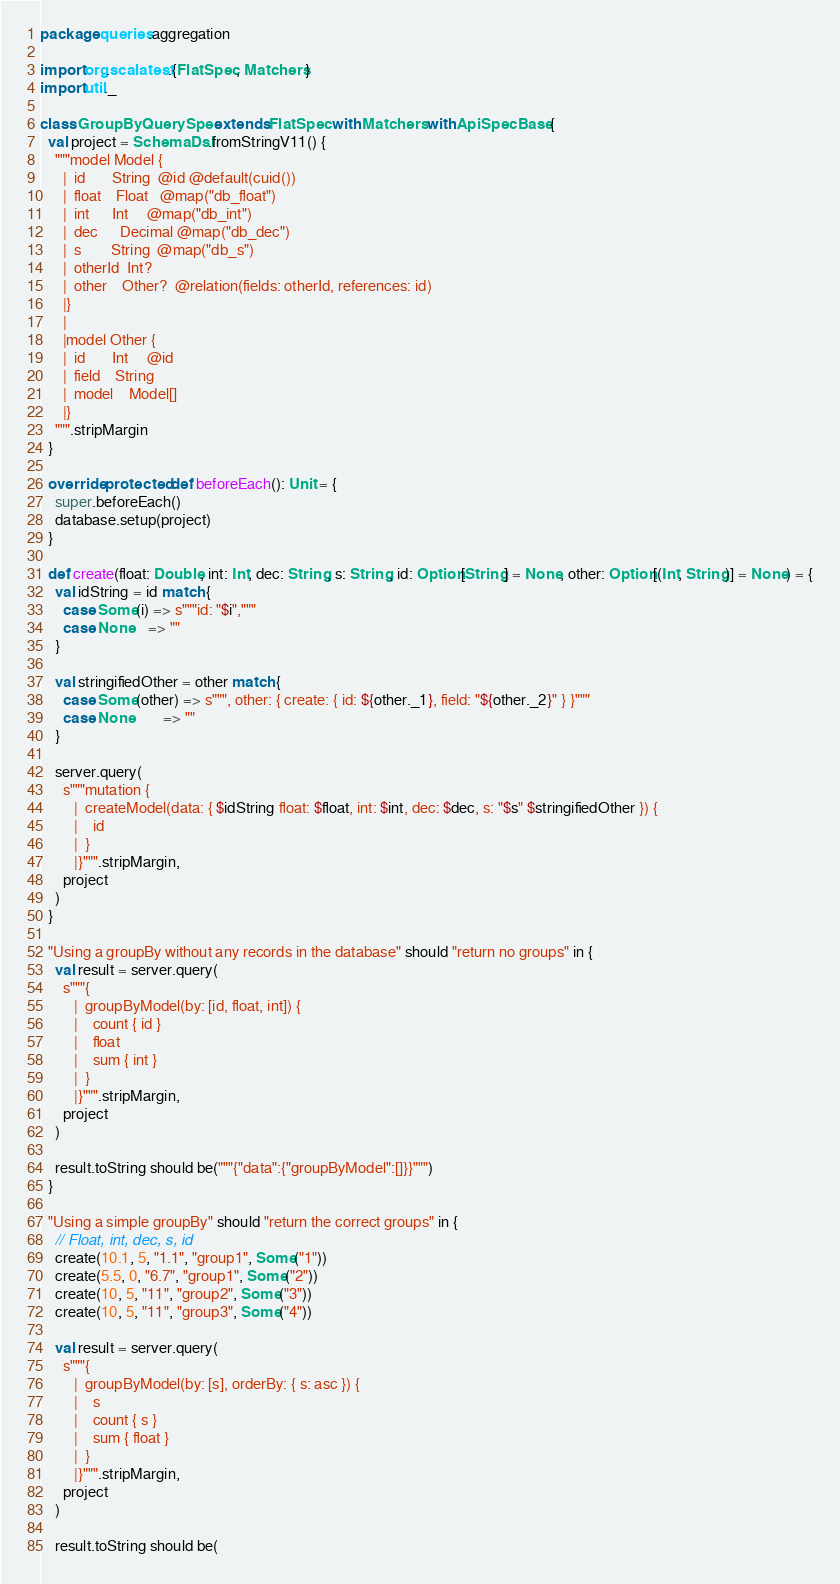Convert code to text. <code><loc_0><loc_0><loc_500><loc_500><_Scala_>package queries.aggregation

import org.scalatest.{FlatSpec, Matchers}
import util._

class GroupByQuerySpec extends FlatSpec with Matchers with ApiSpecBase {
  val project = SchemaDsl.fromStringV11() {
    """model Model {
      |  id       String  @id @default(cuid())
      |  float    Float   @map("db_float")
      |  int      Int     @map("db_int")
      |  dec      Decimal @map("db_dec")
      |  s        String  @map("db_s")
      |  otherId  Int?
      |  other    Other?  @relation(fields: otherId, references: id)
      |}
      |
      |model Other {
      |  id       Int     @id
      |  field    String
      |  model    Model[]
      |}
    """.stripMargin
  }

  override protected def beforeEach(): Unit = {
    super.beforeEach()
    database.setup(project)
  }

  def create(float: Double, int: Int, dec: String, s: String, id: Option[String] = None, other: Option[(Int, String)] = None) = {
    val idString = id match {
      case Some(i) => s"""id: "$i","""
      case None    => ""
    }

    val stringifiedOther = other match {
      case Some(other) => s""", other: { create: { id: ${other._1}, field: "${other._2}" } }"""
      case None        => ""
    }

    server.query(
      s"""mutation {
         |  createModel(data: { $idString float: $float, int: $int, dec: $dec, s: "$s" $stringifiedOther }) {
         |    id
         |  }
         |}""".stripMargin,
      project
    )
  }

  "Using a groupBy without any records in the database" should "return no groups" in {
    val result = server.query(
      s"""{
         |  groupByModel(by: [id, float, int]) {
         |    count { id }
         |    float
         |    sum { int }
         |  }
         |}""".stripMargin,
      project
    )

    result.toString should be("""{"data":{"groupByModel":[]}}""")
  }

  "Using a simple groupBy" should "return the correct groups" in {
    // Float, int, dec, s, id
    create(10.1, 5, "1.1", "group1", Some("1"))
    create(5.5, 0, "6.7", "group1", Some("2"))
    create(10, 5, "11", "group2", Some("3"))
    create(10, 5, "11", "group3", Some("4"))

    val result = server.query(
      s"""{
         |  groupByModel(by: [s], orderBy: { s: asc }) {
         |    s
         |    count { s }
         |    sum { float }
         |  }
         |}""".stripMargin,
      project
    )

    result.toString should be(</code> 